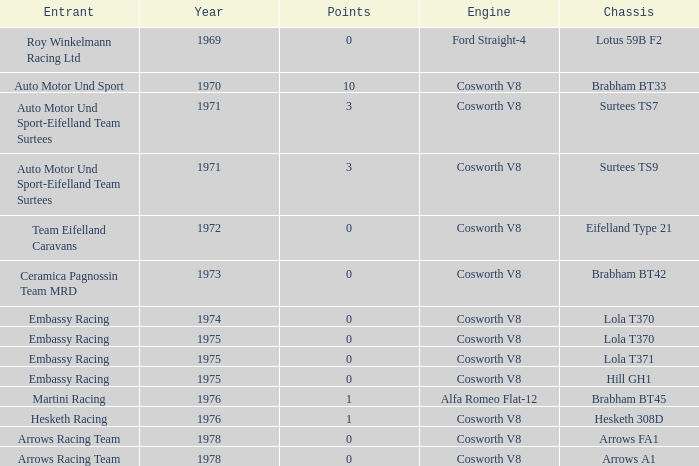In 1970, what entrant had a cosworth v8 engine? Auto Motor Und Sport. 